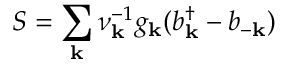<formula> <loc_0><loc_0><loc_500><loc_500>S = \sum _ { k } \nu _ { k } ^ { - 1 } g _ { k } ( b _ { k } ^ { \dagger } - b _ { - k } )</formula> 